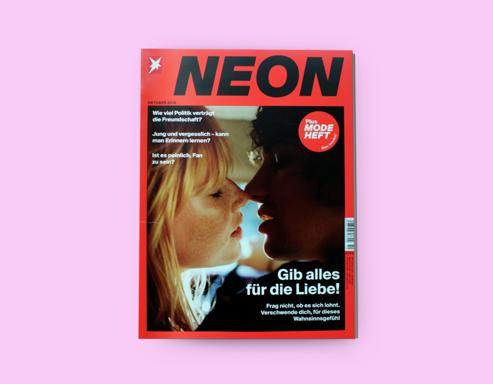What is the message or theme emphasized on the magazine cover? The theme emphasized on the magazine cover is 'Gib alles für die Liebe,' which translates to 'Give everything for love.' This passionate declaration is coupled with an intimate image of two people about to kiss, thereby visually representing the theme and invoking a strong emotional response regarding the intensity and dedication associated with love. 